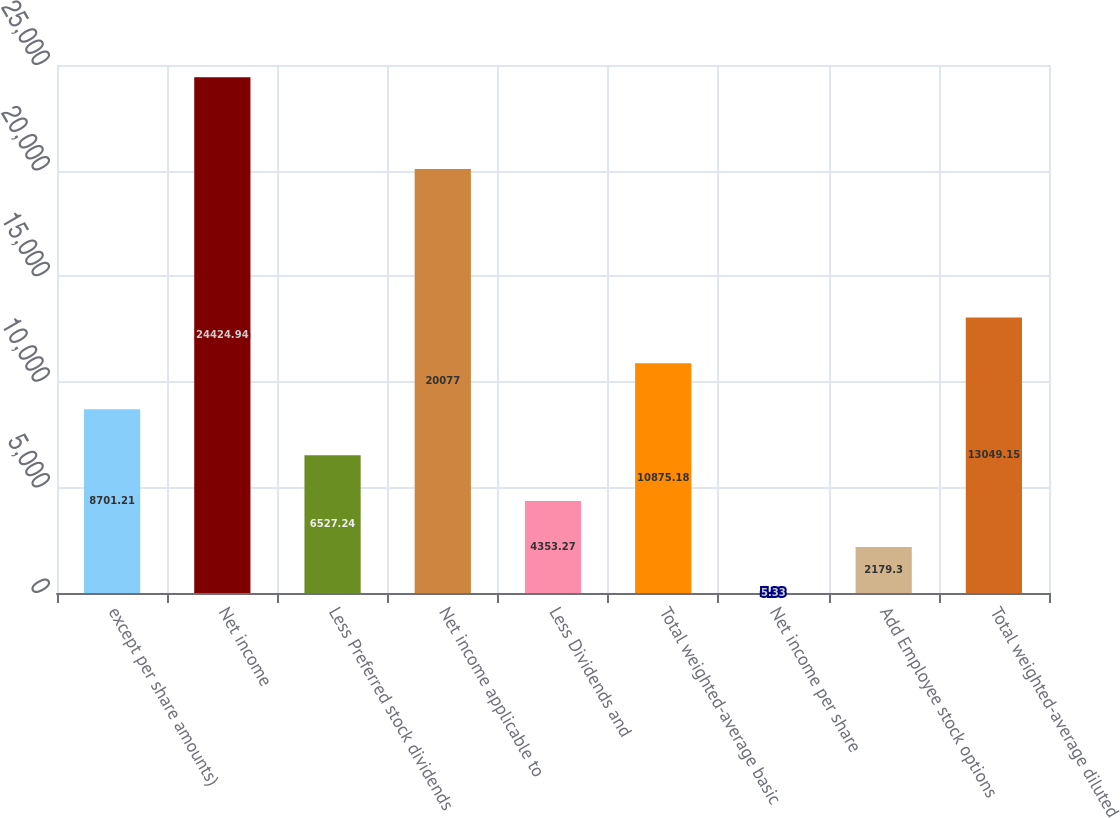Convert chart. <chart><loc_0><loc_0><loc_500><loc_500><bar_chart><fcel>except per share amounts)<fcel>Net income<fcel>Less Preferred stock dividends<fcel>Net income applicable to<fcel>Less Dividends and<fcel>Total weighted-average basic<fcel>Net income per share<fcel>Add Employee stock options<fcel>Total weighted-average diluted<nl><fcel>8701.21<fcel>24424.9<fcel>6527.24<fcel>20077<fcel>4353.27<fcel>10875.2<fcel>5.33<fcel>2179.3<fcel>13049.1<nl></chart> 